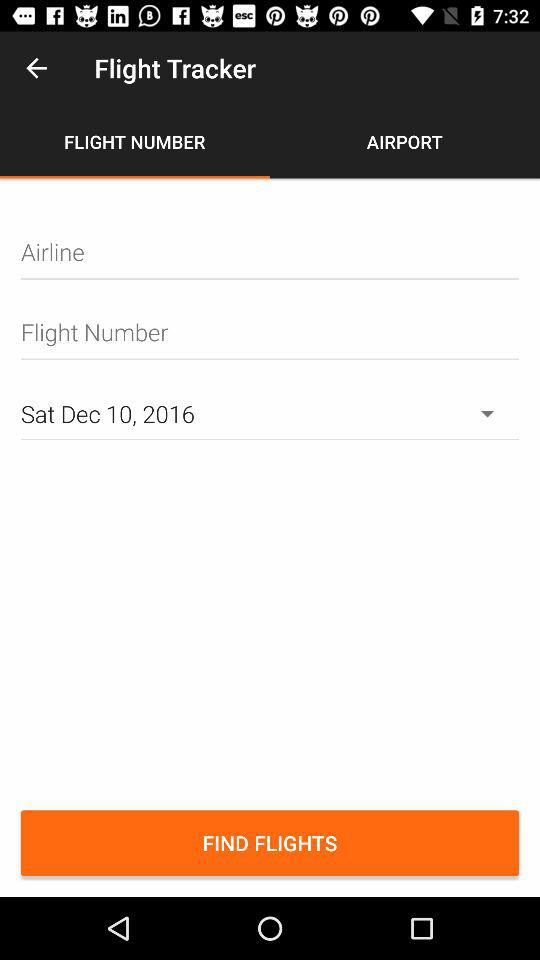What is the day on Dec 10, 2016? The day is Saturday. 